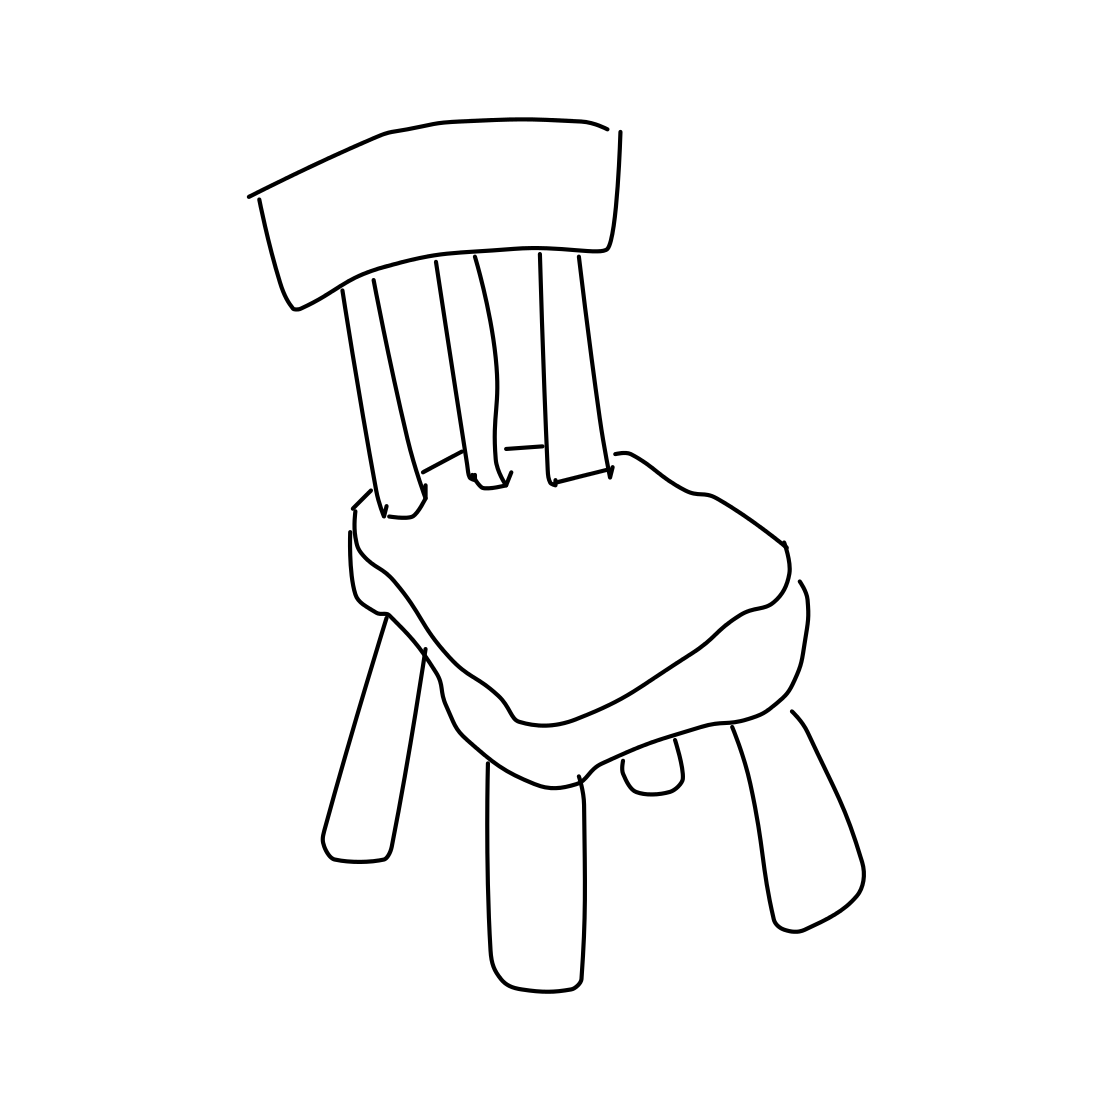Is there a sketchy spider in the picture? No, there isn't a sketchy spider visible in the image. The picture features only a simple outline sketch of a chair with no other elements or details such as spiders or decorations. 